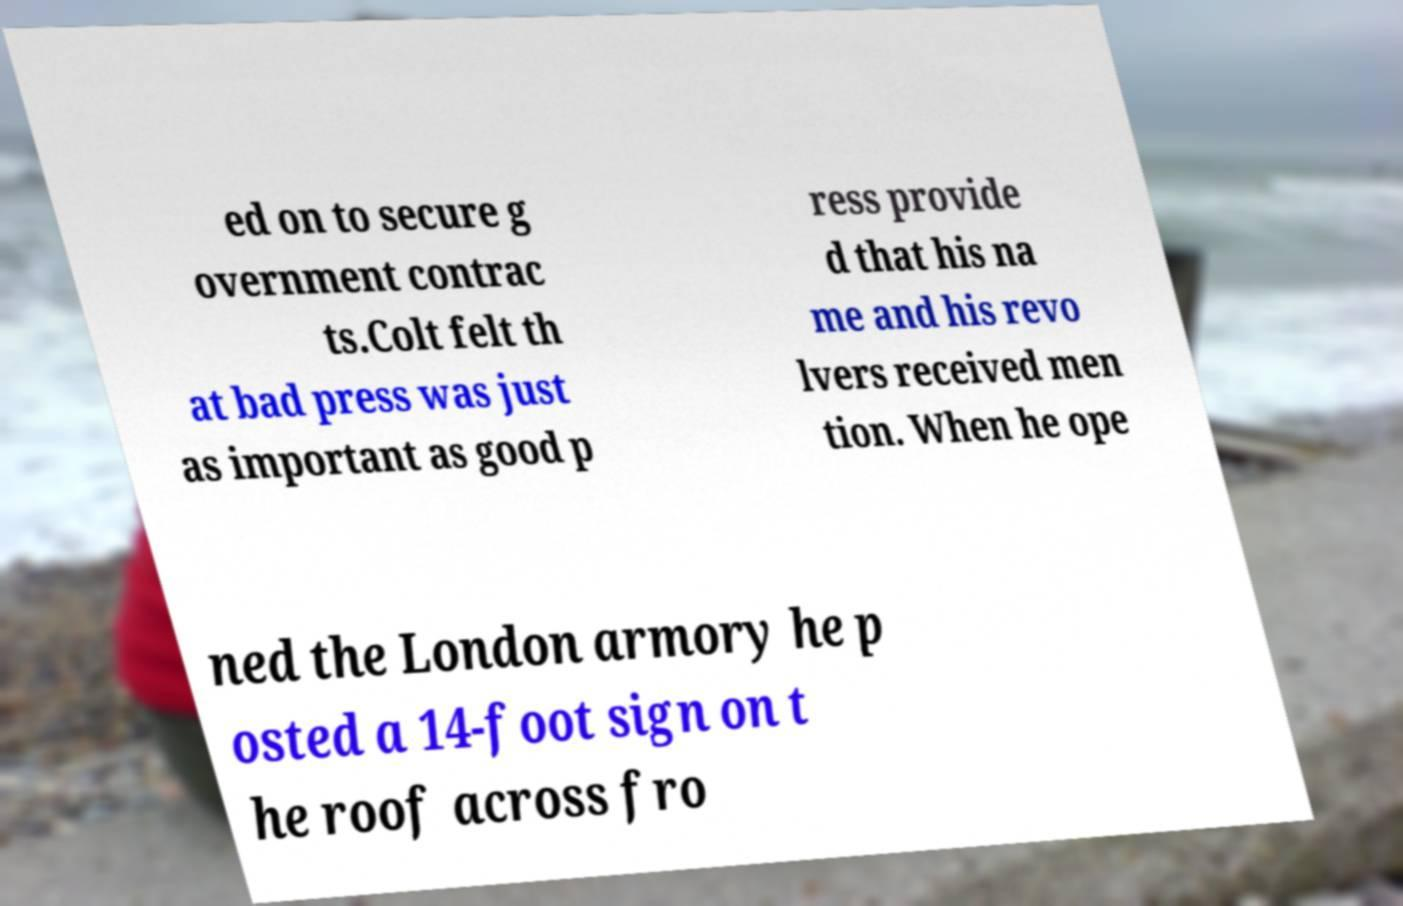Please read and relay the text visible in this image. What does it say? ed on to secure g overnment contrac ts.Colt felt th at bad press was just as important as good p ress provide d that his na me and his revo lvers received men tion. When he ope ned the London armory he p osted a 14-foot sign on t he roof across fro 